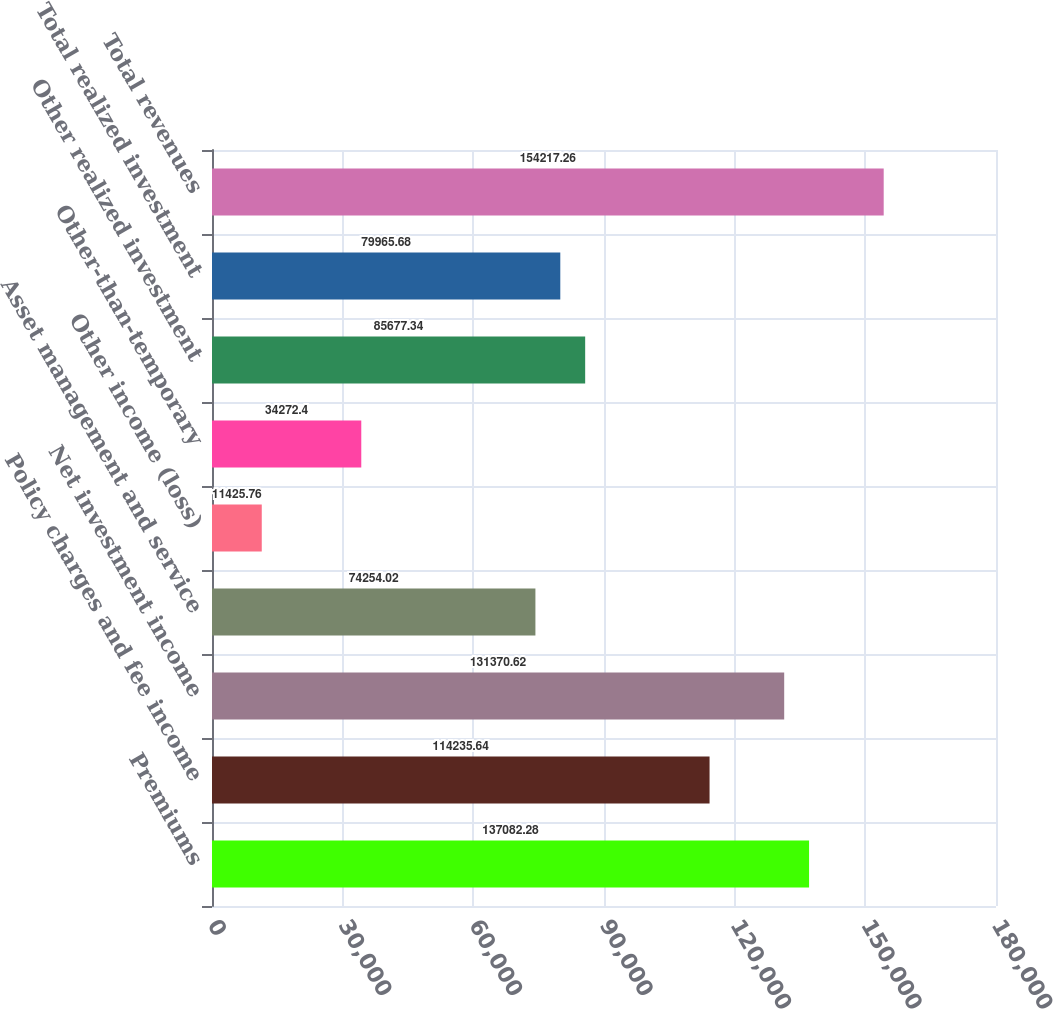Convert chart. <chart><loc_0><loc_0><loc_500><loc_500><bar_chart><fcel>Premiums<fcel>Policy charges and fee income<fcel>Net investment income<fcel>Asset management and service<fcel>Other income (loss)<fcel>Other-than-temporary<fcel>Other realized investment<fcel>Total realized investment<fcel>Total revenues<nl><fcel>137082<fcel>114236<fcel>131371<fcel>74254<fcel>11425.8<fcel>34272.4<fcel>85677.3<fcel>79965.7<fcel>154217<nl></chart> 